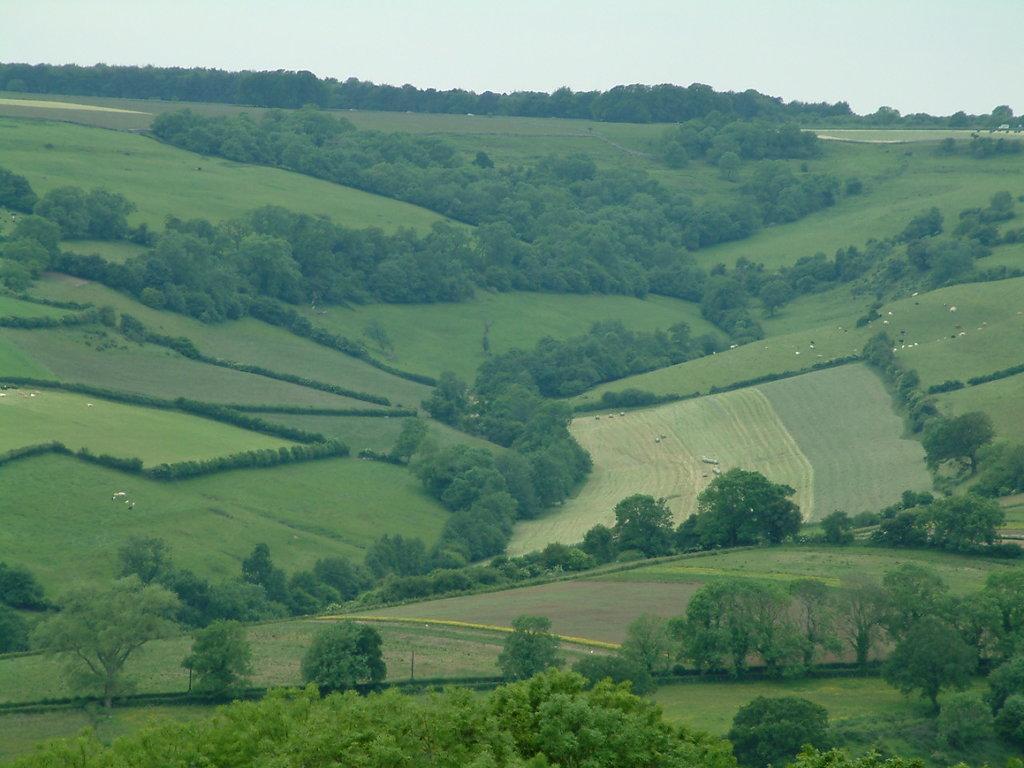Could you give a brief overview of what you see in this image? In this picture we can see there are trees, fields and the sky. 